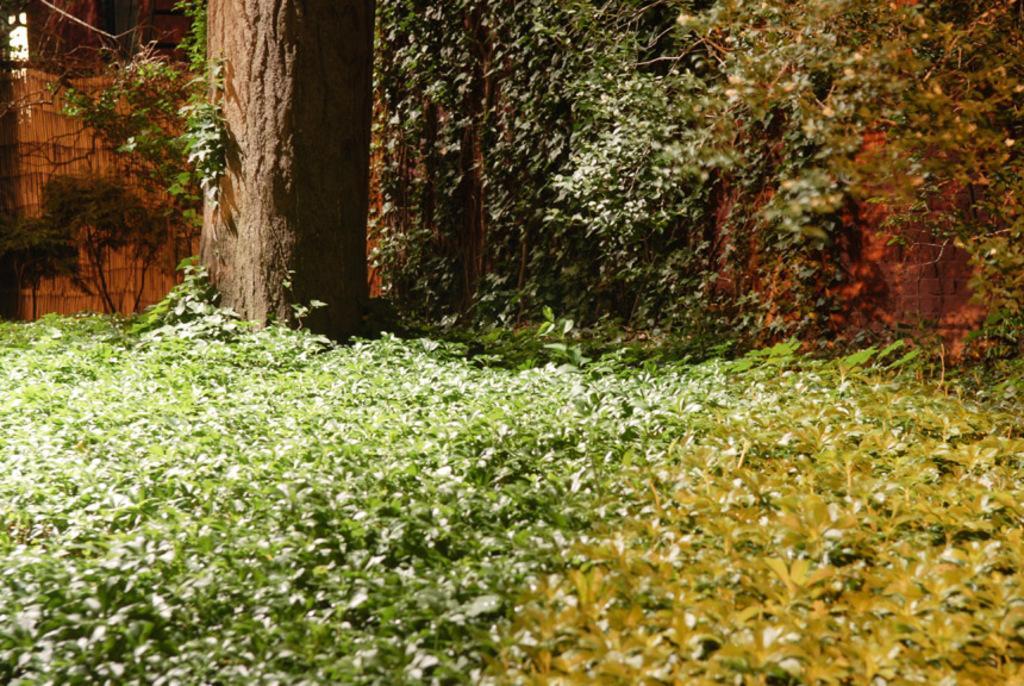Describe this image in one or two sentences. These are the plants and on the left side it is a branch of a tree. 